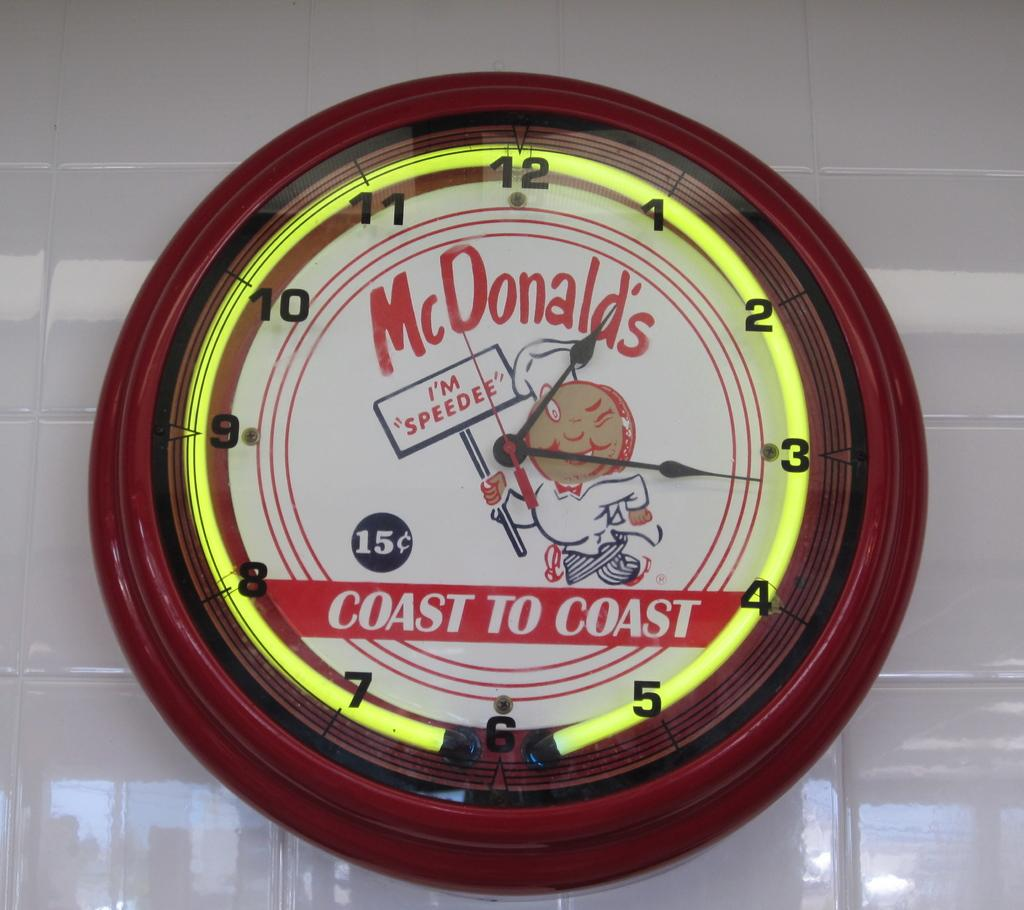<image>
Create a compact narrative representing the image presented. A red circular McDonald's clock showing the time to be 1:17. 